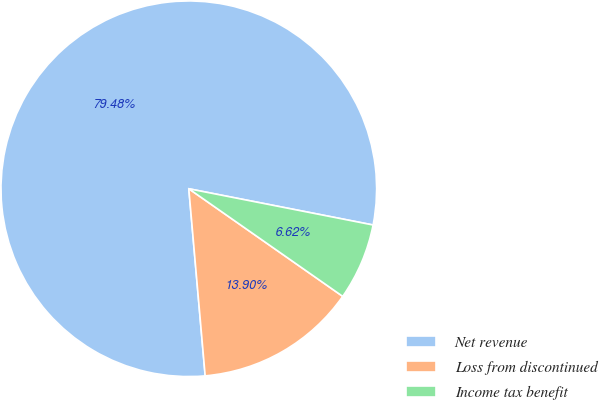Convert chart to OTSL. <chart><loc_0><loc_0><loc_500><loc_500><pie_chart><fcel>Net revenue<fcel>Loss from discontinued<fcel>Income tax benefit<nl><fcel>79.48%<fcel>13.9%<fcel>6.62%<nl></chart> 